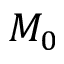<formula> <loc_0><loc_0><loc_500><loc_500>M _ { 0 }</formula> 